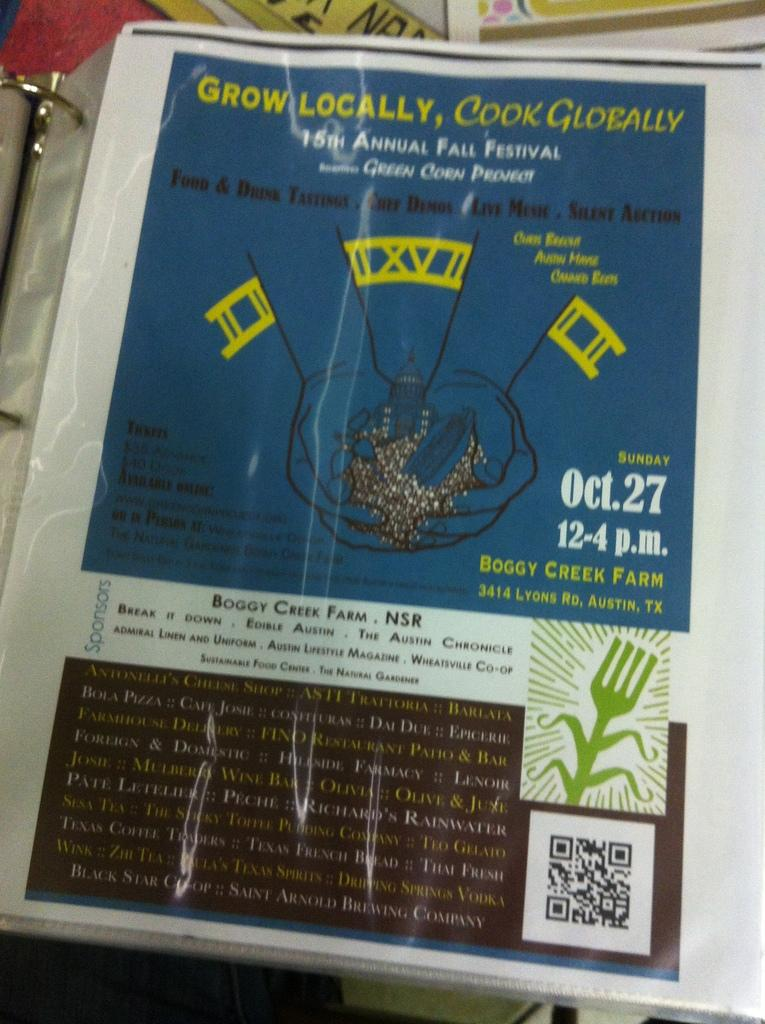Provide a one-sentence caption for the provided image. Boggy Creek Farm presents the 15th Annual Fall Festival on Oct 27. 